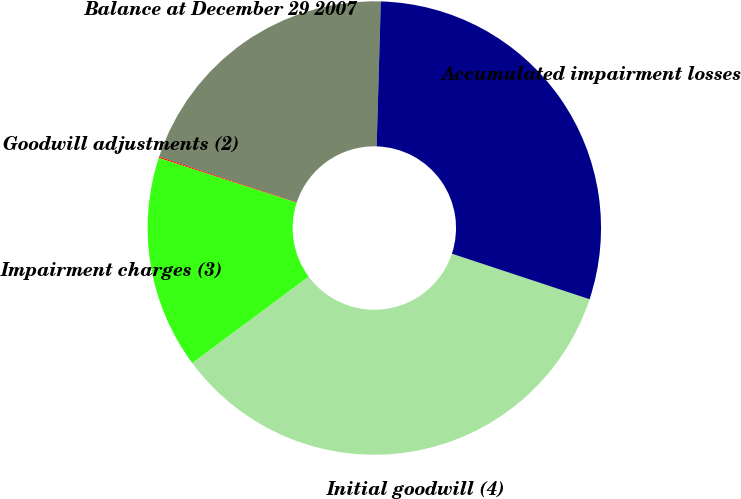Convert chart. <chart><loc_0><loc_0><loc_500><loc_500><pie_chart><fcel>Balance at December 29 2007<fcel>Goodwill adjustments (2)<fcel>Impairment charges (3)<fcel>Initial goodwill (4)<fcel>Accumulated impairment losses<nl><fcel>20.37%<fcel>0.08%<fcel>15.17%<fcel>34.75%<fcel>29.63%<nl></chart> 